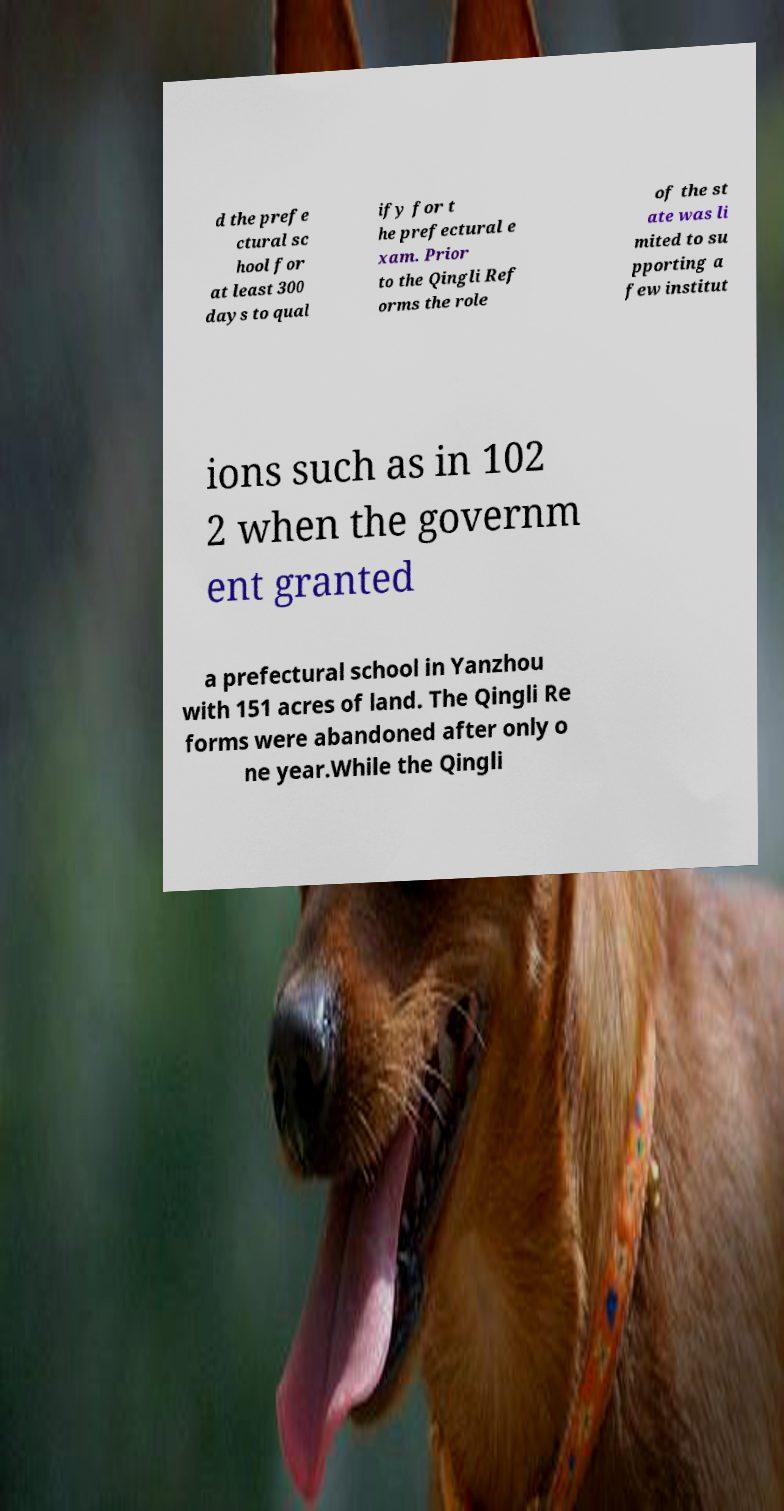Please read and relay the text visible in this image. What does it say? d the prefe ctural sc hool for at least 300 days to qual ify for t he prefectural e xam. Prior to the Qingli Ref orms the role of the st ate was li mited to su pporting a few institut ions such as in 102 2 when the governm ent granted a prefectural school in Yanzhou with 151 acres of land. The Qingli Re forms were abandoned after only o ne year.While the Qingli 